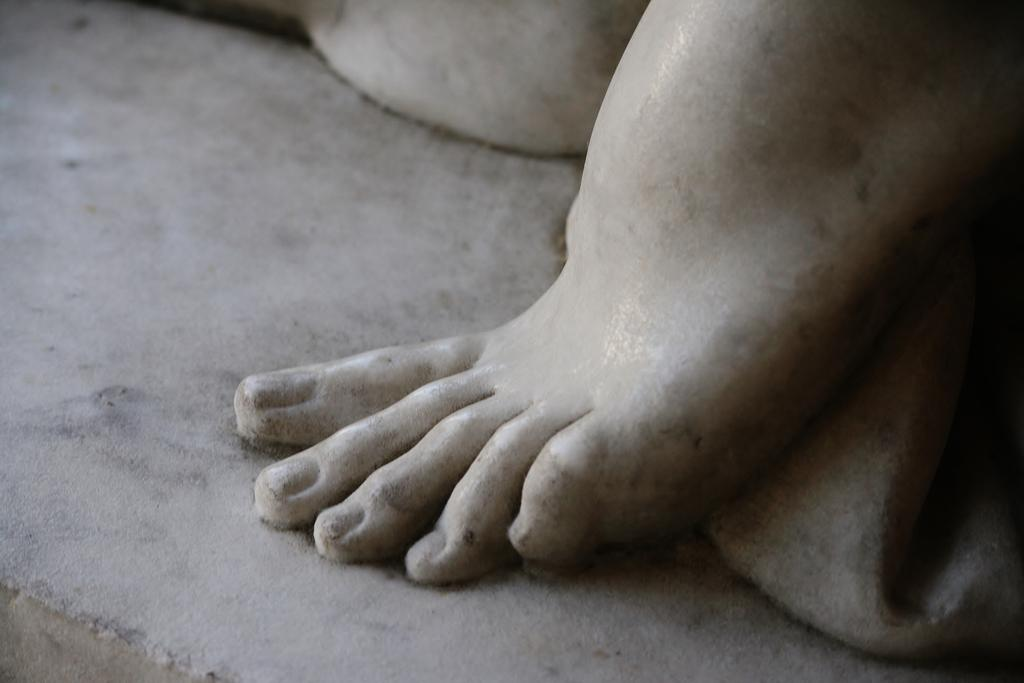What is the main subject of the image? There is a sculpture in the image. What is the sculpture depicting? The sculpture is of human feet. Where is the sculpture located in the image? The sculpture is in the middle of the image. What type of knot is being tied by the flame in the image? There is no knot or flame present in the image; it features a sculpture of human feet. What is the name of the competition that the sculpture is participating in? The image does not depict a competition, and the sculpture is not participating in any event. 